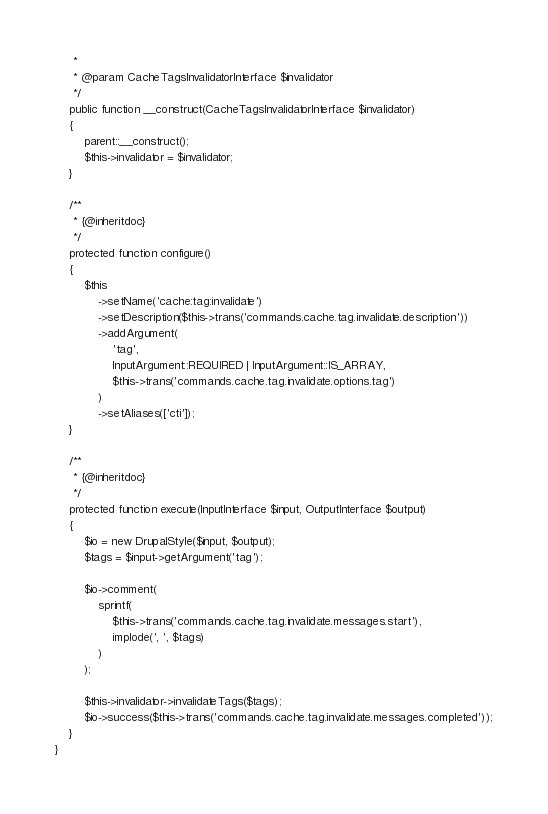<code> <loc_0><loc_0><loc_500><loc_500><_PHP_>     *
     * @param CacheTagsInvalidatorInterface $invalidator
     */
    public function __construct(CacheTagsInvalidatorInterface $invalidator)
    {
        parent::__construct();
        $this->invalidator = $invalidator;
    }

    /**
     * {@inheritdoc}
     */
    protected function configure()
    {
        $this
            ->setName('cache:tag:invalidate')
            ->setDescription($this->trans('commands.cache.tag.invalidate.description'))
            ->addArgument(
                'tag',
                InputArgument::REQUIRED | InputArgument::IS_ARRAY,
                $this->trans('commands.cache.tag.invalidate.options.tag')
            )
            ->setAliases(['cti']);
    }

    /**
     * {@inheritdoc}
     */
    protected function execute(InputInterface $input, OutputInterface $output)
    {
        $io = new DrupalStyle($input, $output);
        $tags = $input->getArgument('tag');

        $io->comment(
            sprintf(
                $this->trans('commands.cache.tag.invalidate.messages.start'),
                implode(', ', $tags)
            )
        );

        $this->invalidator->invalidateTags($tags);
        $io->success($this->trans('commands.cache.tag.invalidate.messages.completed'));
    }
}
</code> 